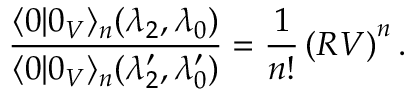<formula> <loc_0><loc_0><loc_500><loc_500>\frac { \langle 0 | 0 _ { V } \rangle _ { n } ( \lambda _ { 2 } , \lambda _ { 0 } ) } { \langle 0 | 0 _ { V } \rangle _ { n } ( { \lambda } _ { 2 } ^ { \prime } , { \lambda } _ { 0 } ^ { \prime } ) } = \frac { 1 } { n ! } \left ( R V \right ) ^ { n } .</formula> 